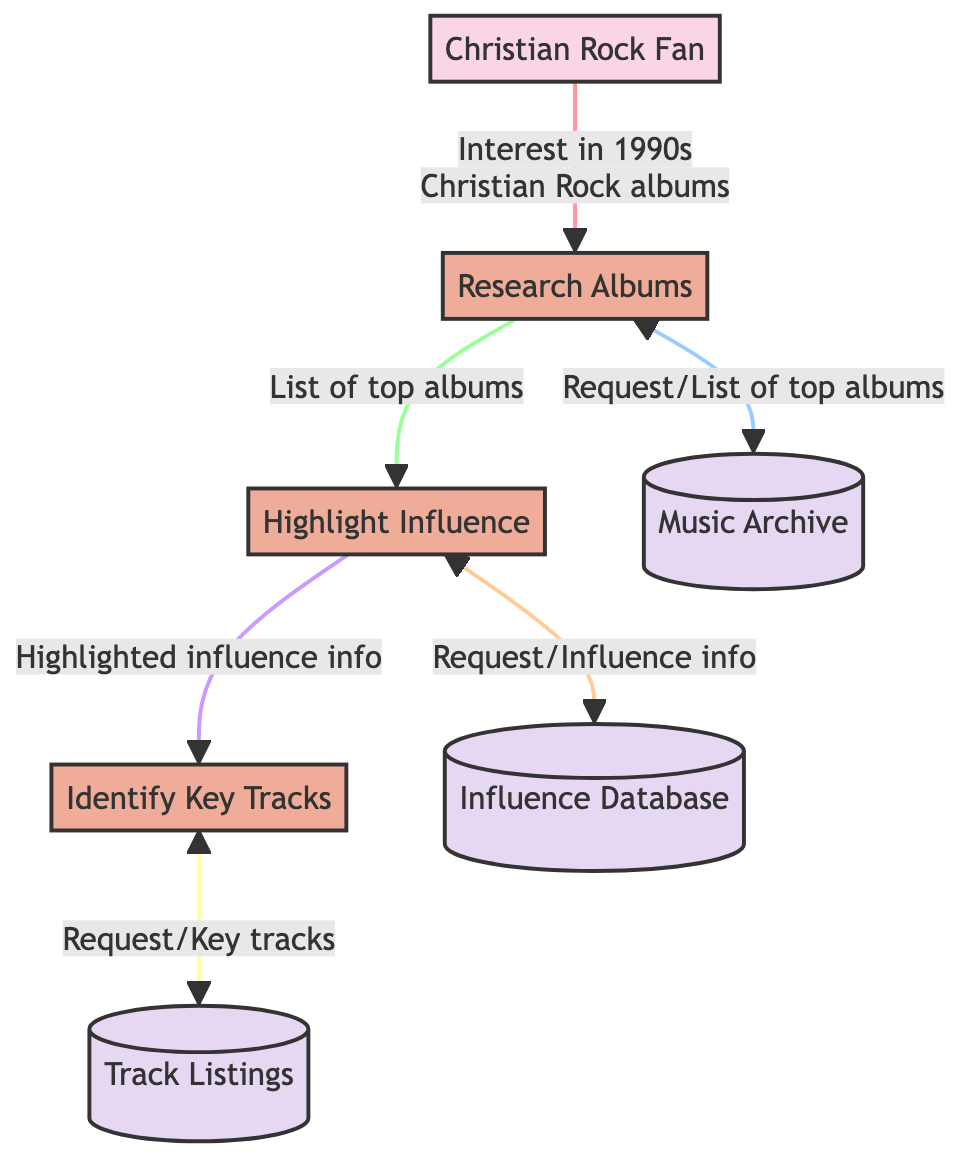What is the first process initiated by the Christian Rock Fan? The diagram shows that the Christian Rock Fan initiates the flow by expressing their interest, which leads to the process of researching albums.
Answer: Research Albums How many entities are represented in the diagram? The diagram lists two entities: the Christian Rock Fan and Album. Therefore, counting both gives us a total of two.
Answer: 2 What type of data flows from the Music Archive to the Research Albums process? The Music Archive provides a list of top Christian Rock albums in response to a request made by the Research Albums process.
Answer: List of top Christian Rock albums of the 1990s Which database contains influence information for the albums? The diagram indicates the presence of an Influence Database that specifically stores information on the cultural and musical impact of the albums.
Answer: Influence Database What is the outcome of the Highlight Influence process? The Highlight Influence process produces highlighted influence information which is then passed to the Identify Key Tracks process.
Answer: Highlighted influence information for each album What happens after the Identify Key Tracks process requests key tracks? After requesting key tracks, the Identify Key Tracks process receives the key tracks from the Track Listings datastore, completing the flow.
Answer: Key tracks of each album Does the track listings process have a direct connection to the Christian Rock Fan? The diagram shows that the Identify Key Tracks process directly leads to the Track Listings, meaning there is no direct connection between Track Listings and the Christian Rock Fan.
Answer: No Which process uses information from both the Highlight Influence and Identify Key Tracks processes? The diagram illustrates that the Identify Key Tracks process receives highlighted influence information from Highlight Influence and utilizes that to process various key tracks.
Answer: Identify Key Tracks 